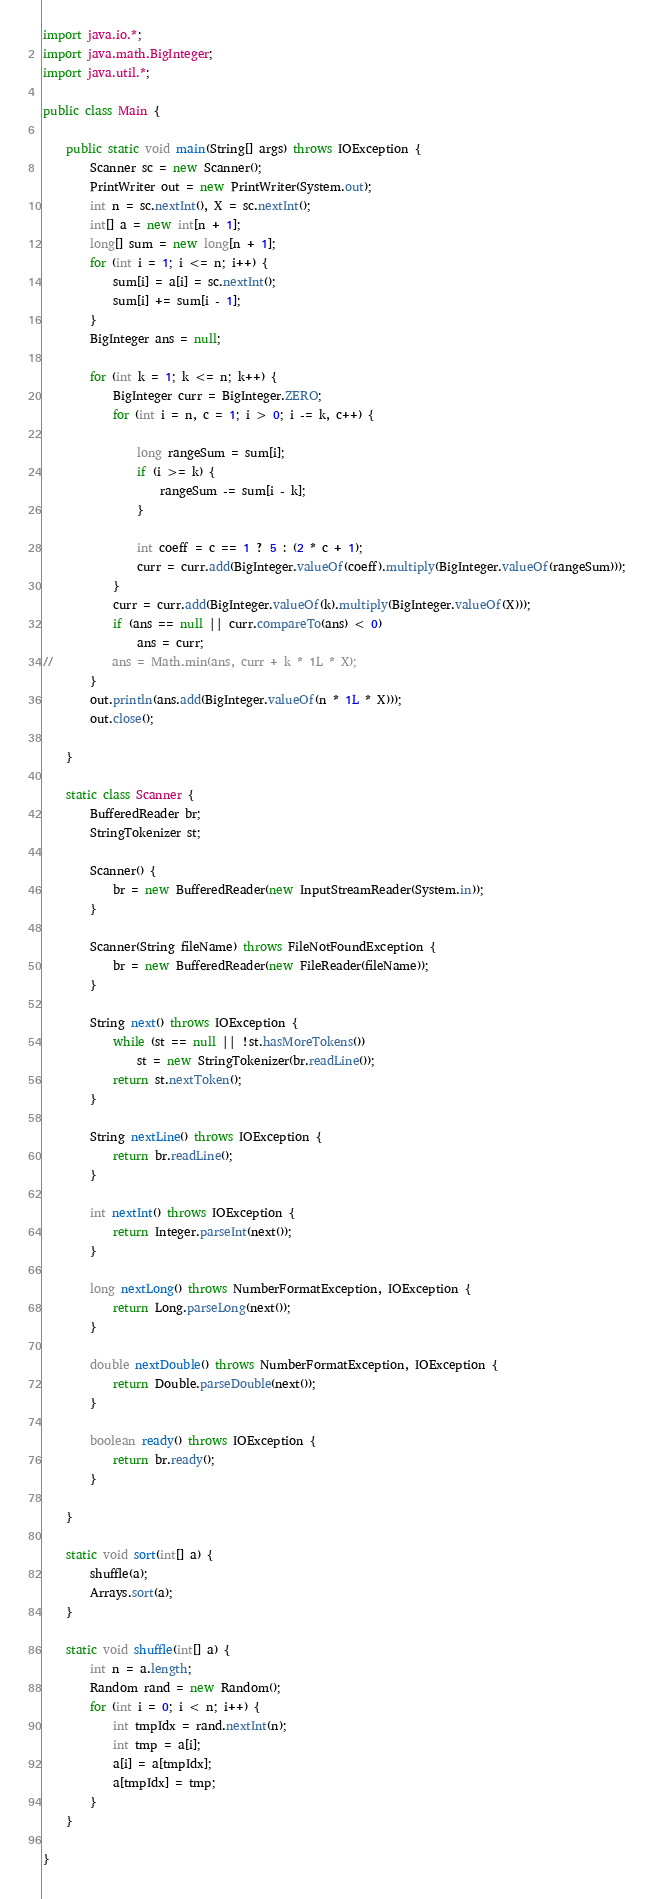<code> <loc_0><loc_0><loc_500><loc_500><_Java_>import java.io.*;
import java.math.BigInteger;
import java.util.*;

public class Main {

	public static void main(String[] args) throws IOException {
		Scanner sc = new Scanner();
		PrintWriter out = new PrintWriter(System.out);
		int n = sc.nextInt(), X = sc.nextInt();
		int[] a = new int[n + 1];
		long[] sum = new long[n + 1];
		for (int i = 1; i <= n; i++) {
			sum[i] = a[i] = sc.nextInt();
			sum[i] += sum[i - 1];
		}
		BigInteger ans = null;

		for (int k = 1; k <= n; k++) {
			BigInteger curr = BigInteger.ZERO;
			for (int i = n, c = 1; i > 0; i -= k, c++) {

				long rangeSum = sum[i];
				if (i >= k) {
					rangeSum -= sum[i - k];
				}

				int coeff = c == 1 ? 5 : (2 * c + 1);
				curr = curr.add(BigInteger.valueOf(coeff).multiply(BigInteger.valueOf(rangeSum)));
			}
			curr = curr.add(BigInteger.valueOf(k).multiply(BigInteger.valueOf(X)));
			if (ans == null || curr.compareTo(ans) < 0)
				ans = curr;
//			ans = Math.min(ans, curr + k * 1L * X);
		}
		out.println(ans.add(BigInteger.valueOf(n * 1L * X)));
		out.close();

	}

	static class Scanner {
		BufferedReader br;
		StringTokenizer st;

		Scanner() {
			br = new BufferedReader(new InputStreamReader(System.in));
		}

		Scanner(String fileName) throws FileNotFoundException {
			br = new BufferedReader(new FileReader(fileName));
		}

		String next() throws IOException {
			while (st == null || !st.hasMoreTokens())
				st = new StringTokenizer(br.readLine());
			return st.nextToken();
		}

		String nextLine() throws IOException {
			return br.readLine();
		}

		int nextInt() throws IOException {
			return Integer.parseInt(next());
		}

		long nextLong() throws NumberFormatException, IOException {
			return Long.parseLong(next());
		}

		double nextDouble() throws NumberFormatException, IOException {
			return Double.parseDouble(next());
		}

		boolean ready() throws IOException {
			return br.ready();
		}

	}

	static void sort(int[] a) {
		shuffle(a);
		Arrays.sort(a);
	}

	static void shuffle(int[] a) {
		int n = a.length;
		Random rand = new Random();
		for (int i = 0; i < n; i++) {
			int tmpIdx = rand.nextInt(n);
			int tmp = a[i];
			a[i] = a[tmpIdx];
			a[tmpIdx] = tmp;
		}
	}

}</code> 